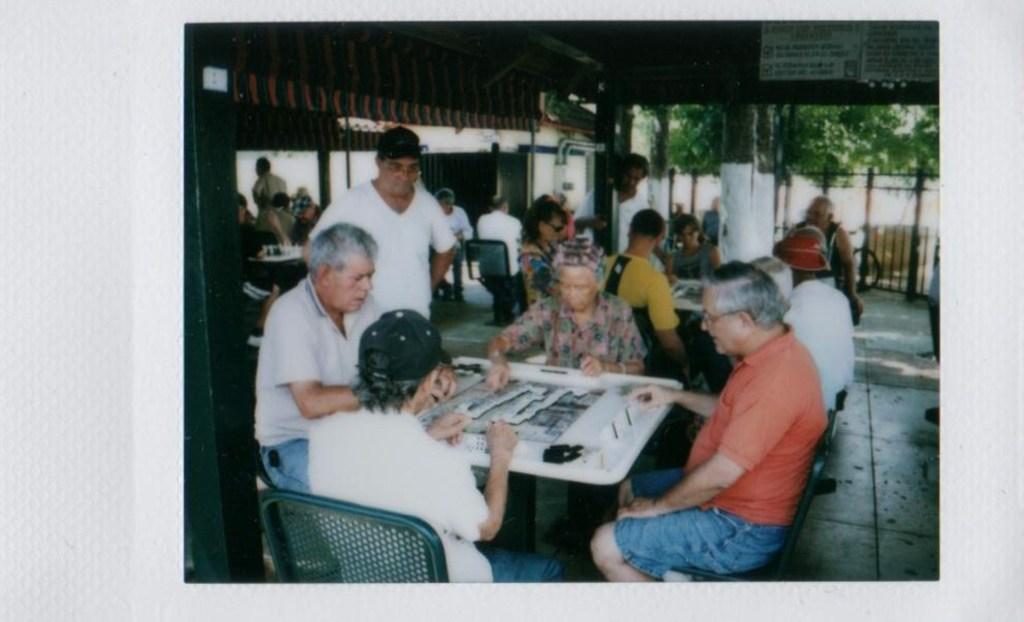Please provide a concise description of this image. This is a photograph in which people are sitting on the chair at the table. In the background there are poles,trees and wall. 